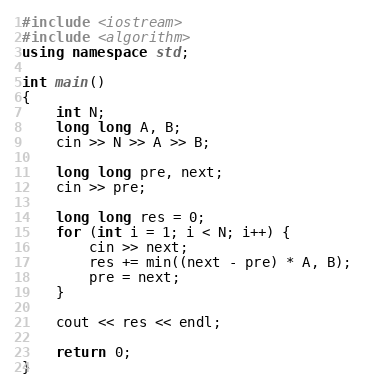<code> <loc_0><loc_0><loc_500><loc_500><_C++_>#include <iostream>
#include <algorithm>
using namespace std;

int main()
{
	int N;
	long long A, B;
	cin >> N >> A >> B;

	long long pre, next;
	cin >> pre;
	
	long long res = 0;
	for (int i = 1; i < N; i++) {
		cin >> next;
		res += min((next - pre) * A, B);
		pre = next;
	}

	cout << res << endl;

	return 0;
}

</code> 